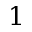<formula> <loc_0><loc_0><loc_500><loc_500>1</formula> 